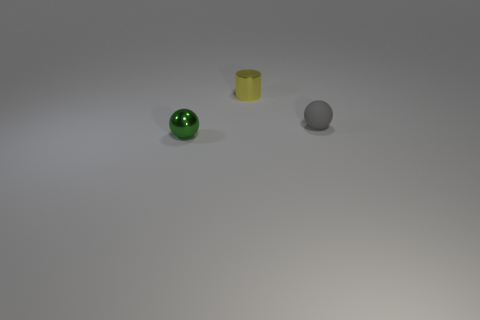Is there anything else of the same color as the rubber object?
Make the answer very short. No. What shape is the thing that is the same material as the small yellow cylinder?
Keep it short and to the point. Sphere. There is a yellow metal cylinder behind the tiny metallic object in front of the tiny gray thing; how many tiny rubber spheres are behind it?
Your answer should be very brief. 0. There is a object that is both in front of the tiny yellow object and to the left of the tiny rubber ball; what is its shape?
Offer a very short reply. Sphere. Are there fewer small yellow shiny objects that are on the left side of the tiny metal cylinder than large cyan metal cubes?
Offer a very short reply. No. How many big things are gray balls or shiny blocks?
Offer a very short reply. 0. The metallic sphere has what size?
Give a very brief answer. Small. Are there any other things that are made of the same material as the yellow object?
Offer a terse response. Yes. What number of small rubber spheres are on the right side of the green metallic ball?
Your answer should be very brief. 1. What is the size of the green object that is the same shape as the tiny gray rubber thing?
Provide a succinct answer. Small. 